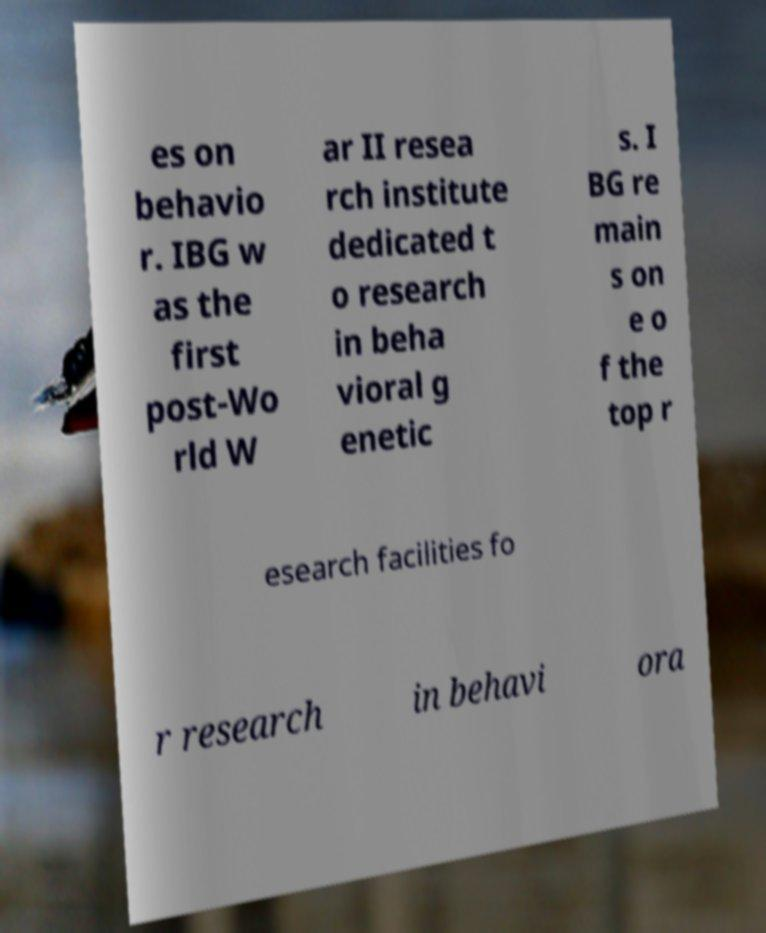What messages or text are displayed in this image? I need them in a readable, typed format. es on behavio r. IBG w as the first post-Wo rld W ar II resea rch institute dedicated t o research in beha vioral g enetic s. I BG re main s on e o f the top r esearch facilities fo r research in behavi ora 